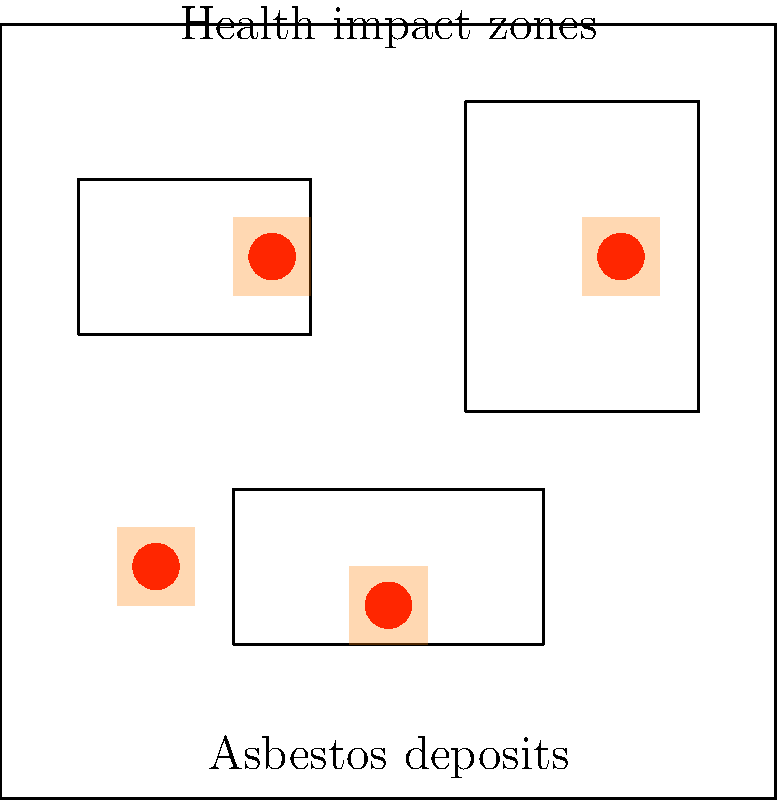Based on the global distribution of asbestos deposits shown in the map, what conclusion can be drawn about the correlation between asbestos deposits and regional health statistics? To analyze the correlation between asbestos deposits and regional health statistics, we need to follow these steps:

1. Observe the asbestos deposits:
   - Red dots represent asbestos deposits on the map.
   - There are four distinct deposit locations.

2. Identify health impact zones:
   - Orange shaded areas represent regions with health impacts.
   - There are four health impact zones on the map.

3. Compare deposit locations with health impact zones:
   - Each asbestos deposit is surrounded by or very close to a health impact zone.
   - There is a clear spatial correlation between deposits and impact zones.

4. Consider the implications:
   - The visual evidence suggests a strong correlation between asbestos deposits and negative health outcomes in nearby regions.
   - This correlation contradicts the belief that asbestos is harmless.

5. Evaluate the global distribution:
   - Asbestos deposits are spread across different continents or regions.
   - Health impact zones consistently appear near these deposits, regardless of location.

6. Draw a conclusion:
   - The global distribution of asbestos deposits shows a consistent pattern of nearby health impacts.
   - This suggests a causal relationship between asbestos exposure and health issues.

Despite the persona's belief, the data visualization provides strong evidence of a positive correlation between asbestos deposits and negative health outcomes on a global scale.
Answer: Positive correlation between asbestos deposits and regional health impacts 